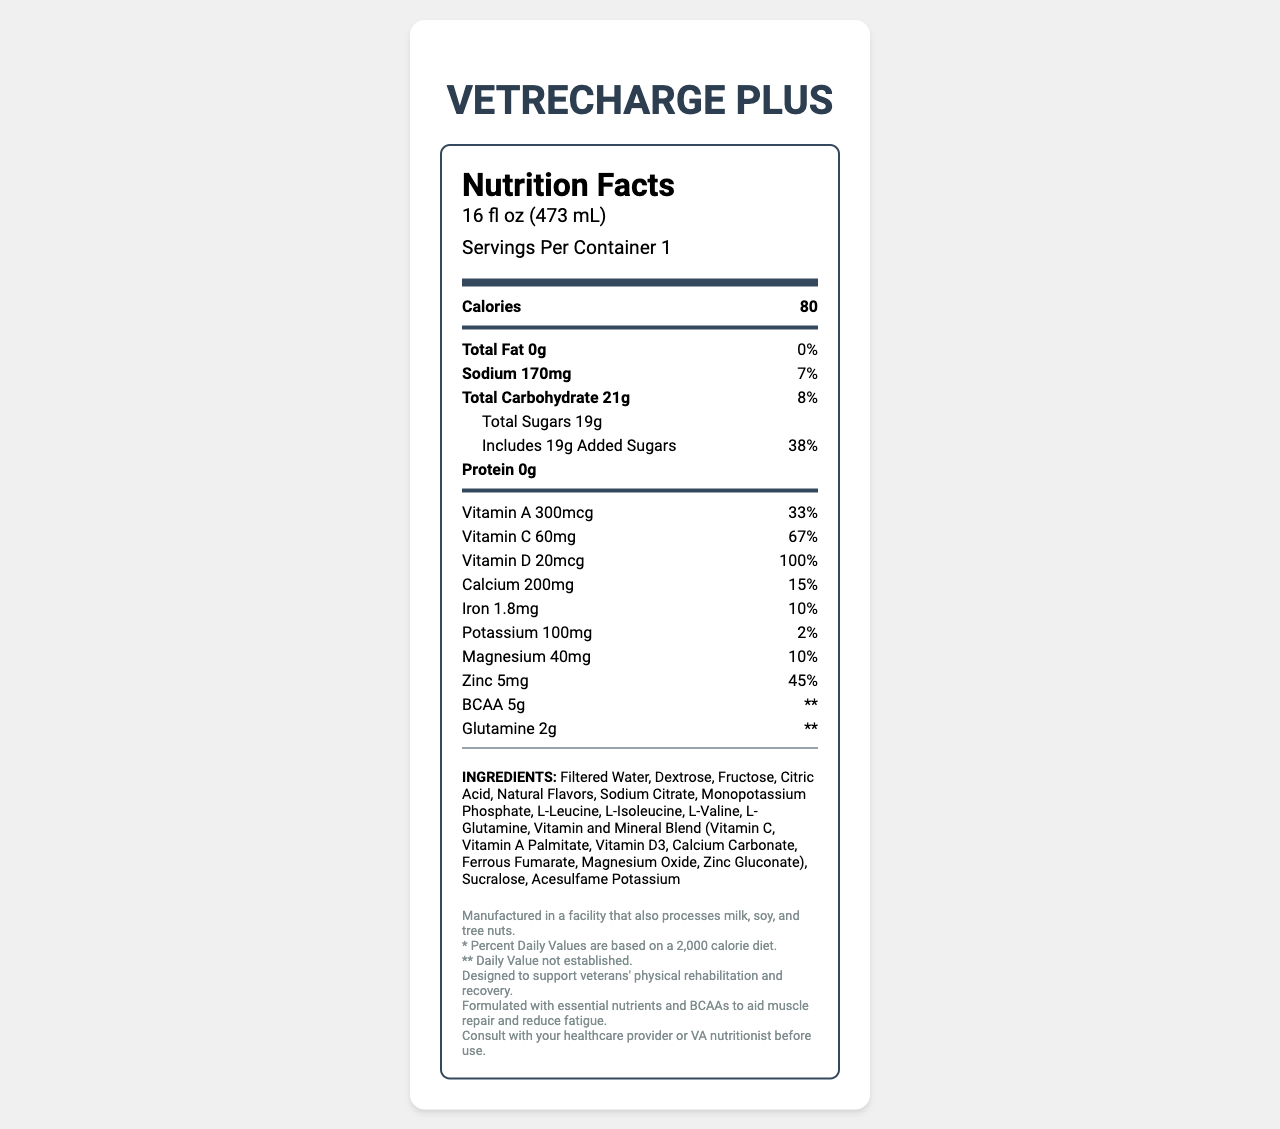what is the serving size of VetRecharge Plus? The serving size is clearly mentioned in the document as "16 fl oz (473 mL)".
Answer: 16 fl oz (473 mL) how many servings are there per container of VetRecharge Plus? The document states there is 1 serving per container.
Answer: 1 how many calories are there per serving? The number of calories per serving is specified as 80 in the document.
Answer: 80 what is the total fat content per serving? The document mentions "Total Fat 0g".
Answer: 0g how much sodium is in each serving? According to the document, there is 170mg of sodium per serving.
Answer: 170mg how many grams of total carbohydrates are in each serving? The total carbohydrate content per serving is listed as 21g.
Answer: 21g what percentage of the daily value for vitamin D does this product provide? The document states that it provides 100% of the daily value for vitamin D.
Answer: 100% what ingredient is listed first in the ingredients list? The ingredients list starts with "Filtered Water".
Answer: Filtered Water What are the BCAAs mentioned in the document used for? The document notes that BCAAs are formulated to aid muscle repair and reduce fatigue.
Answer: Aid muscle repair and reduce fatigue What is the percentage daily value of added sugars per serving? The document specifies that the added sugars contribute 38% of the daily value.
Answer: 38% How much protein does VetRecharge Plus contain? The document specifies that the protein content per serving is 0g.
Answer: 0g What is the percent daily value of zinc in VetRecharge Plus? A. 10% B. 15% C. 33% D. 45% According to the document, the percentage daily value of zinc in the product is 45%.
Answer: D. 45% Which of the following nutrients does VetRecharge Plus provide the highest percentage daily value of? A. Vitamin A B. Vitamin C C. Vitamin D D. Calcium Vitamin D has the highest percentage daily value at 100%, according to the document.
Answer: C. Vitamin D Is VetRecharge Plus free from allergens? The document notes that it is manufactured in a facility that also processes milk, soy, and tree nuts.
Answer: No Summarize the key nutritional benefits of VetRecharge Plus. VetRecharge Plus offers various vitamins and minerals essential for recovery and rehabilitation, along with added BCAAs and glutamine for muscle support.
Answer: VetRecharge Plus is a fortified sports drink designed to support veterans' physical rehabilitation and recovery, providing essential nutrients such as vitamins A, C, D, calcium, iron, potassium, magnesium, and zinc. It also contains BCAAs and glutamine to aid muscle repair and reduce fatigue. How much vitamin B12 does VetRecharge Plus contain? The document does not mention vitamin B12 or its quantity.
Answer: Not enough information 